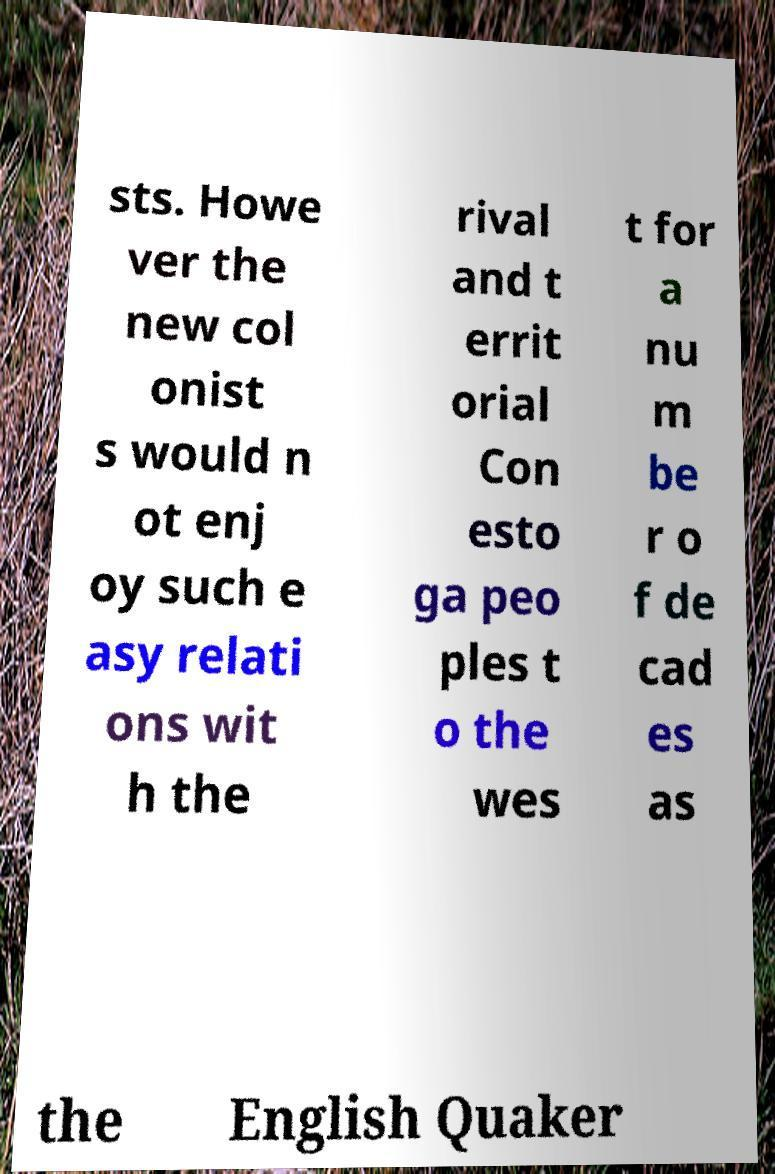Could you extract and type out the text from this image? sts. Howe ver the new col onist s would n ot enj oy such e asy relati ons wit h the rival and t errit orial Con esto ga peo ples t o the wes t for a nu m be r o f de cad es as the English Quaker 